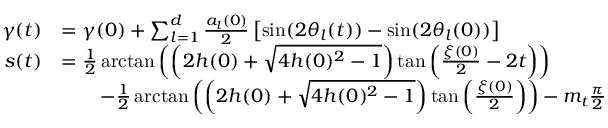<formula> <loc_0><loc_0><loc_500><loc_500>\begin{array} { r l } { \gamma ( t ) } & { = \gamma ( 0 ) + \sum _ { l = 1 } ^ { d } \frac { a _ { l } ( 0 ) } { 2 } \left [ \sin ( 2 \theta _ { l } ( t ) ) - \sin ( 2 \theta _ { l } ( 0 ) ) \right ] } \\ { s ( t ) } & { = \frac { 1 } { 2 } \arctan \left ( \left ( 2 h ( 0 ) + \sqrt { 4 h ( 0 ) ^ { 2 } - 1 } \right ) \tan \left ( \frac { \xi ( 0 ) } { 2 } - 2 t \right ) \right ) } \\ & { \quad - \frac { 1 } { 2 } \arctan \left ( \left ( 2 h ( 0 ) + \sqrt { 4 h ( 0 ) ^ { 2 } - 1 } \right ) \tan \left ( \frac { \xi ( 0 ) } { 2 } \right ) \right ) - m _ { t } \frac { \pi } { 2 } } \end{array}</formula> 